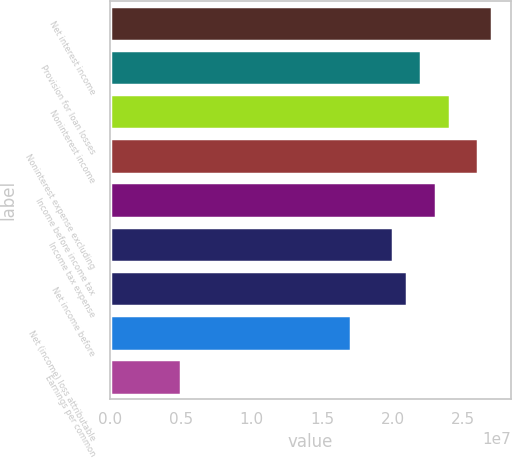Convert chart to OTSL. <chart><loc_0><loc_0><loc_500><loc_500><bar_chart><fcel>Net interest income<fcel>Provision for loan losses<fcel>Noninterest income<fcel>Noninterest expense excluding<fcel>Income before income tax<fcel>Income tax expense<fcel>Net income before<fcel>Net (income) loss attributable<fcel>Earnings per common<nl><fcel>2.70494e+07<fcel>2.20402e+07<fcel>2.40439e+07<fcel>2.60475e+07<fcel>2.3042e+07<fcel>2.00366e+07<fcel>2.10384e+07<fcel>1.70311e+07<fcel>5.00914e+06<nl></chart> 